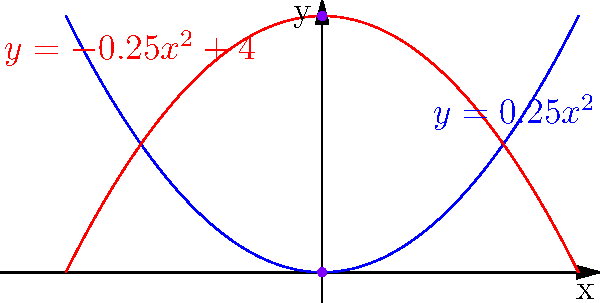As a journalism professor emphasizing fact-checking, you encounter a situation where a student is reporting on a statistical model represented by the equation $4x^2 + 4y^2 - 16y - 16 = 0$. To ensure accuracy in the report, you need to identify the type of conic section this equation represents and sketch its graph. What type of conic section is this, and what are its key characteristics? To identify the type of conic section and its characteristics, let's follow these steps:

1) First, we need to rewrite the equation in standard form. The given equation is:
   $4x^2 + 4y^2 - 16y - 16 = 0$

2) Group the y terms:
   $4x^2 + (4y^2 - 16y) - 16 = 0$

3) Complete the square for y:
   $4x^2 + 4(y^2 - 4y + 4 - 4) - 16 = 0$
   $4x^2 + 4(y - 2)^2 - 16 - 16 = 0$

4) Simplify:
   $4x^2 + 4(y - 2)^2 = 32$

5) Divide both sides by 32:
   $\frac{x^2}{8} + \frac{(y - 2)^2}{8} = 1$

6) This is the standard form of an ellipse centered at (0, 2) with a = b = √8.

7) Key characteristics:
   - Center: (0, 2)
   - Major and minor axes are equal (circle)
   - Radius: √8 ≈ 2.83

8) The graph shows two parabolas: $y = 0.25x^2$ and $y = -0.25x^2 + 4$. The intersection of these parabolas forms the circle.

9) The circle passes through the points (0, 0) and (0, 4), which are √8 units apart, confirming our calculated diameter.
Answer: Circle centered at (0, 2) with radius √8 